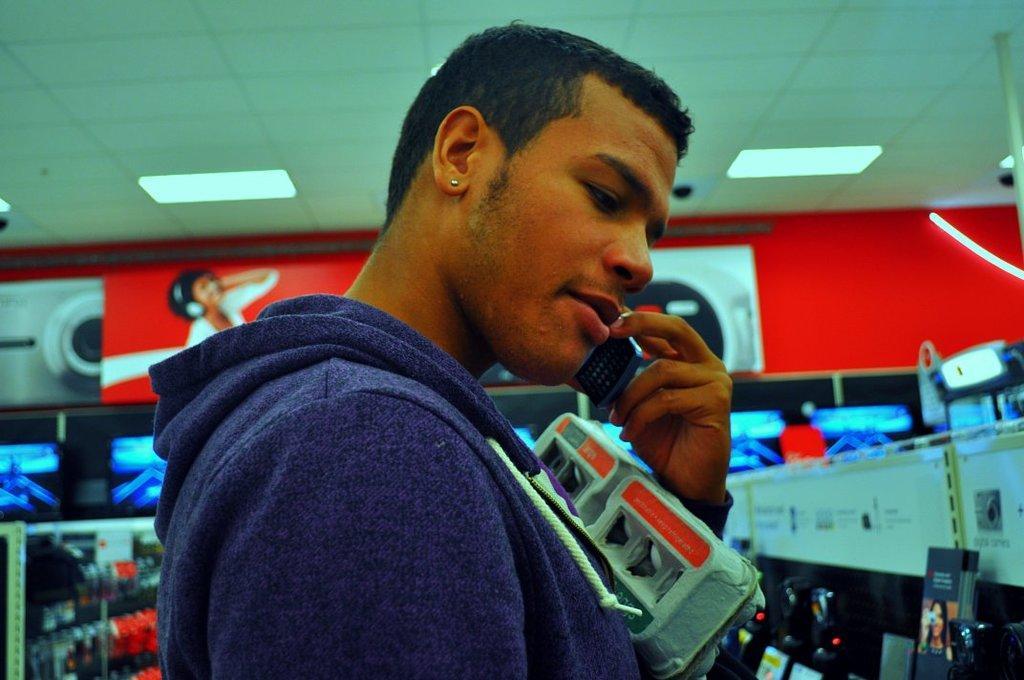In one or two sentences, can you explain what this image depicts? In this image I can see a man is standing and holding some objects. In the background I can see lights on the ceiling and some other objects. 